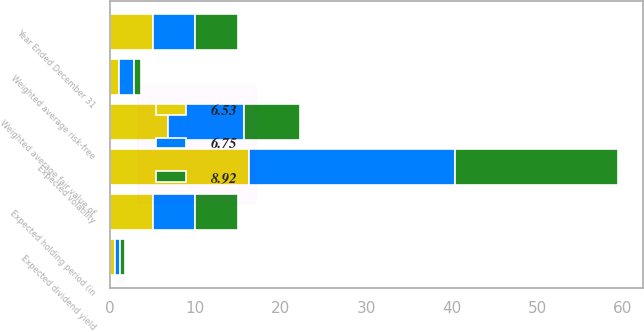Convert chart to OTSL. <chart><loc_0><loc_0><loc_500><loc_500><stacked_bar_chart><ecel><fcel>Year Ended December 31<fcel>Expected dividend yield<fcel>Expected volatility<fcel>Weighted average risk-free<fcel>Expected holding period (in<fcel>Weighted average fair value of<nl><fcel>6.53<fcel>5<fcel>0.6<fcel>16.3<fcel>1.1<fcel>5<fcel>6.75<nl><fcel>8.92<fcel>5<fcel>0.6<fcel>19<fcel>0.8<fcel>5<fcel>6.53<nl><fcel>6.75<fcel>5<fcel>0.6<fcel>24.1<fcel>1.7<fcel>5<fcel>8.92<nl></chart> 